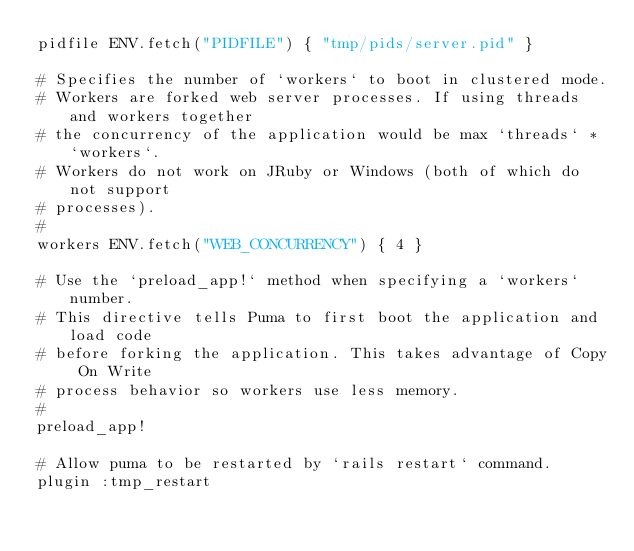<code> <loc_0><loc_0><loc_500><loc_500><_Ruby_>pidfile ENV.fetch("PIDFILE") { "tmp/pids/server.pid" }

# Specifies the number of `workers` to boot in clustered mode.
# Workers are forked web server processes. If using threads and workers together
# the concurrency of the application would be max `threads` * `workers`.
# Workers do not work on JRuby or Windows (both of which do not support
# processes).
#
workers ENV.fetch("WEB_CONCURRENCY") { 4 }

# Use the `preload_app!` method when specifying a `workers` number.
# This directive tells Puma to first boot the application and load code
# before forking the application. This takes advantage of Copy On Write
# process behavior so workers use less memory.
#
preload_app!

# Allow puma to be restarted by `rails restart` command.
plugin :tmp_restart
</code> 